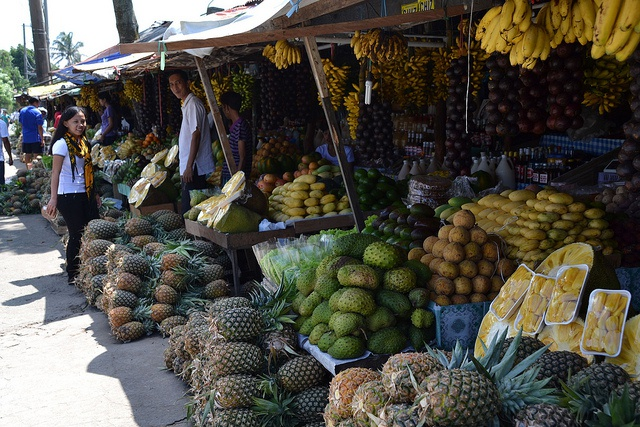Describe the objects in this image and their specific colors. I can see banana in white, black, olive, and maroon tones, people in white, black, lightblue, and gray tones, people in white, black, gray, and darkgray tones, banana in white, olive, black, and maroon tones, and banana in white, olive, and black tones in this image. 